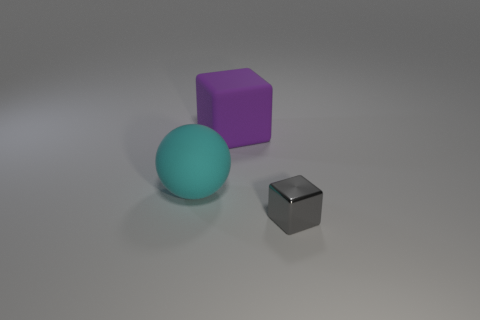What materials do the objects in the image seem to be made of? The objects appear to be made of different materials. The cube seems to be rubber due to its matte finish and slightly soft edges, suggesting it would have a slightly squishy texture. The sphere has a smooth, slightly reflective surface that could suggest a plastic or painted wooden material. Lastly, the smaller object has a metallic finish, indicating it could be made of metal. 